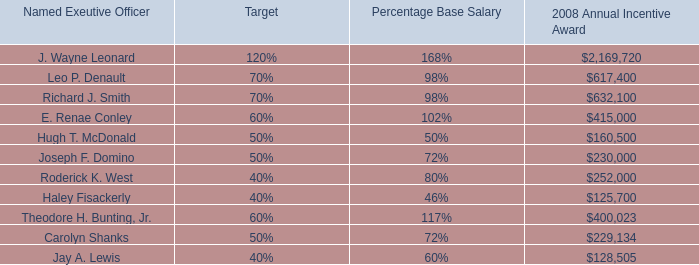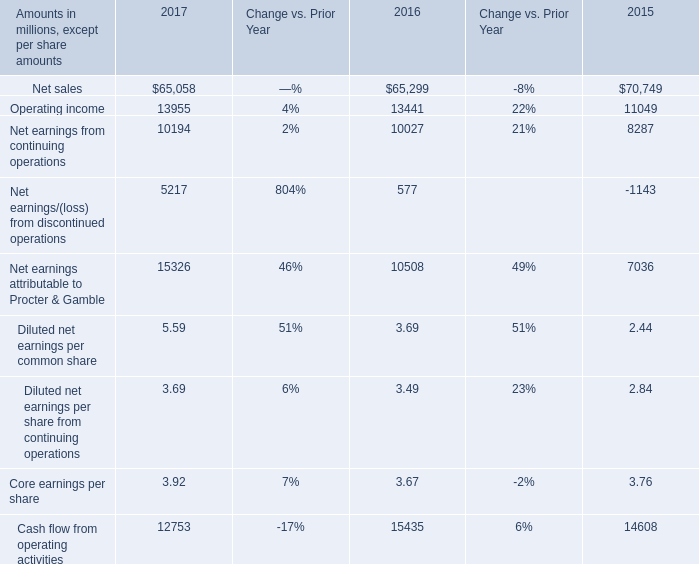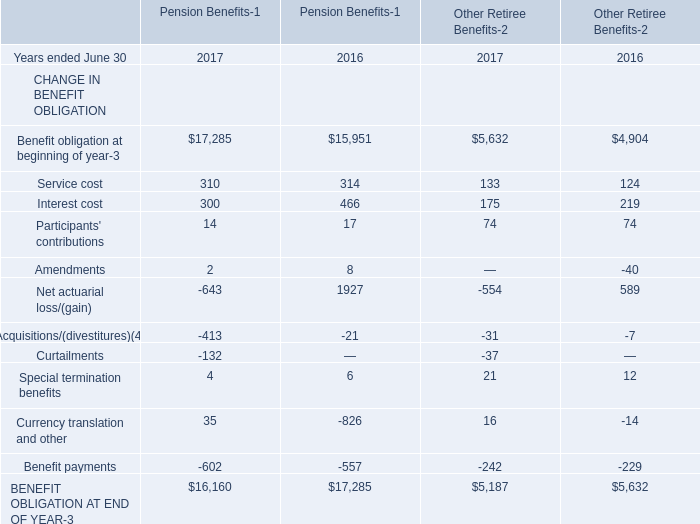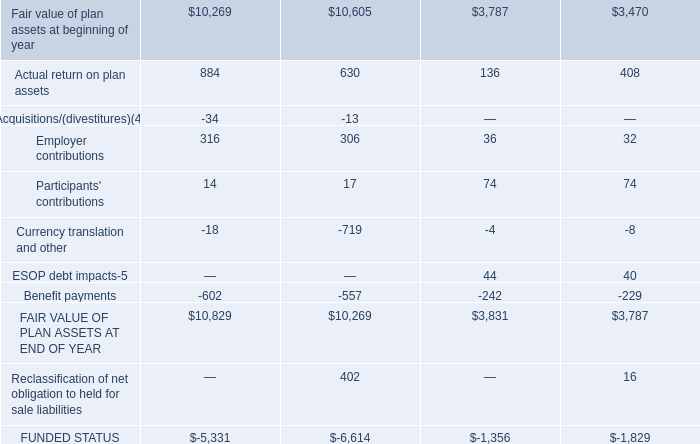In the year ended June 30 where Interest cost for Pension Benefits is the lowest, what's the Interest cost for Other Retiree Benefits? 
Answer: 175. 